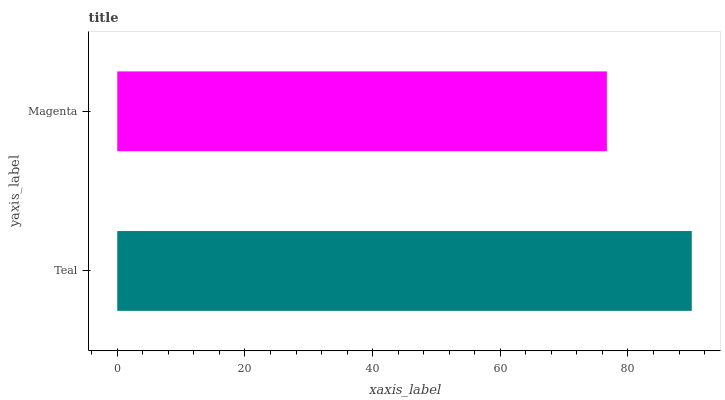Is Magenta the minimum?
Answer yes or no. Yes. Is Teal the maximum?
Answer yes or no. Yes. Is Magenta the maximum?
Answer yes or no. No. Is Teal greater than Magenta?
Answer yes or no. Yes. Is Magenta less than Teal?
Answer yes or no. Yes. Is Magenta greater than Teal?
Answer yes or no. No. Is Teal less than Magenta?
Answer yes or no. No. Is Teal the high median?
Answer yes or no. Yes. Is Magenta the low median?
Answer yes or no. Yes. Is Magenta the high median?
Answer yes or no. No. Is Teal the low median?
Answer yes or no. No. 